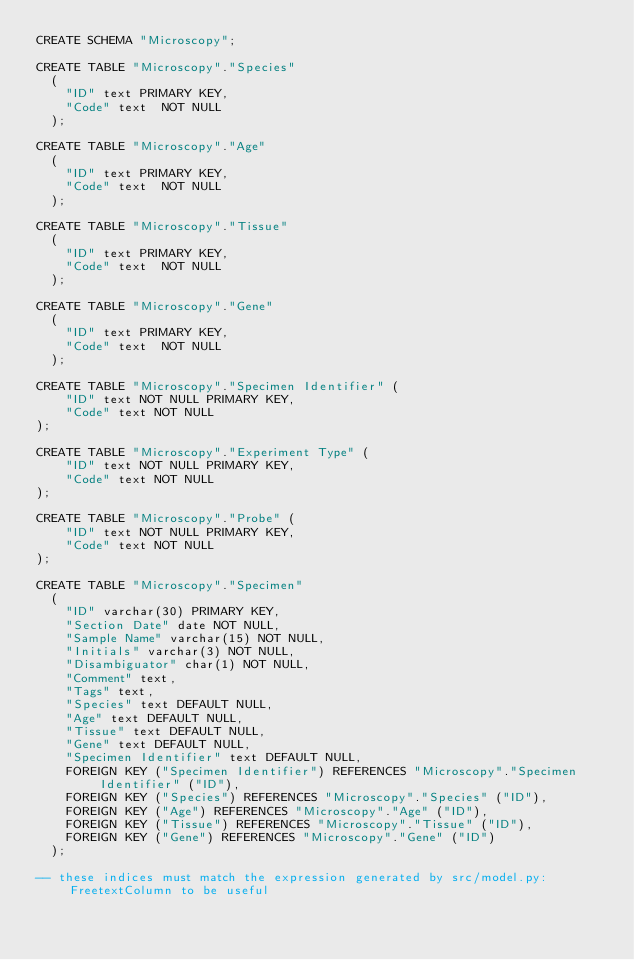Convert code to text. <code><loc_0><loc_0><loc_500><loc_500><_SQL_>CREATE SCHEMA "Microscopy";

CREATE TABLE "Microscopy"."Species"
  (
    "ID" text PRIMARY KEY,
    "Code" text  NOT NULL
  );

CREATE TABLE "Microscopy"."Age"
  (
    "ID" text PRIMARY KEY,
    "Code" text  NOT NULL
  );

CREATE TABLE "Microscopy"."Tissue"
  (
    "ID" text PRIMARY KEY,
    "Code" text  NOT NULL
  );

CREATE TABLE "Microscopy"."Gene"
  (
    "ID" text PRIMARY KEY,
    "Code" text  NOT NULL
  );

CREATE TABLE "Microscopy"."Specimen Identifier" (
    "ID" text NOT NULL PRIMARY KEY,
    "Code" text NOT NULL
);

CREATE TABLE "Microscopy"."Experiment Type" (
    "ID" text NOT NULL PRIMARY KEY,
    "Code" text NOT NULL
);

CREATE TABLE "Microscopy"."Probe" (
    "ID" text NOT NULL PRIMARY KEY,
    "Code" text NOT NULL
);

CREATE TABLE "Microscopy"."Specimen"
  (
    "ID" varchar(30) PRIMARY KEY,
    "Section Date" date NOT NULL,
    "Sample Name" varchar(15) NOT NULL,
    "Initials" varchar(3) NOT NULL,
    "Disambiguator" char(1) NOT NULL,
    "Comment" text,
    "Tags" text,
    "Species" text DEFAULT NULL,
    "Age" text DEFAULT NULL,
    "Tissue" text DEFAULT NULL,
    "Gene" text DEFAULT NULL,
    "Specimen Identifier" text DEFAULT NULL,
    FOREIGN KEY ("Specimen Identifier") REFERENCES "Microscopy"."Specimen Identifier" ("ID"),
    FOREIGN KEY ("Species") REFERENCES "Microscopy"."Species" ("ID"),
    FOREIGN KEY ("Age") REFERENCES "Microscopy"."Age" ("ID"),
    FOREIGN KEY ("Tissue") REFERENCES "Microscopy"."Tissue" ("ID"),
    FOREIGN KEY ("Gene") REFERENCES "Microscopy"."Gene" ("ID")
  );

-- these indices must match the expression generated by src/model.py:FreetextColumn to be useful</code> 